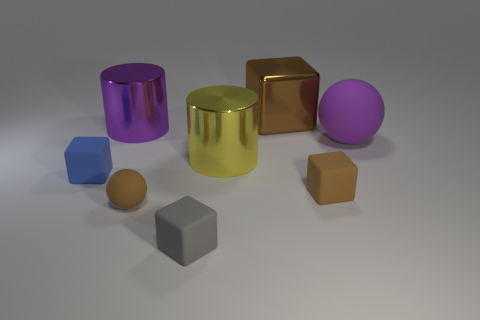The large thing that is the same color as the tiny rubber ball is what shape?
Give a very brief answer. Cube. What is the color of the large shiny thing that is the same shape as the tiny gray thing?
Your answer should be very brief. Brown. Are there the same number of spheres left of the small brown cube and brown things?
Provide a short and direct response. No. How many things are behind the big yellow thing and in front of the brown metal object?
Your answer should be compact. 2. There is a metallic object that is the same shape as the gray matte object; what size is it?
Your answer should be very brief. Large. What number of balls are the same material as the tiny blue block?
Keep it short and to the point. 2. Are there fewer tiny matte balls that are behind the metal cube than tiny brown objects?
Your answer should be compact. Yes. How many large yellow shiny cylinders are there?
Make the answer very short. 1. What number of other tiny blocks are the same color as the metallic block?
Ensure brevity in your answer.  1. Is the small blue rubber thing the same shape as the gray object?
Offer a very short reply. Yes. 